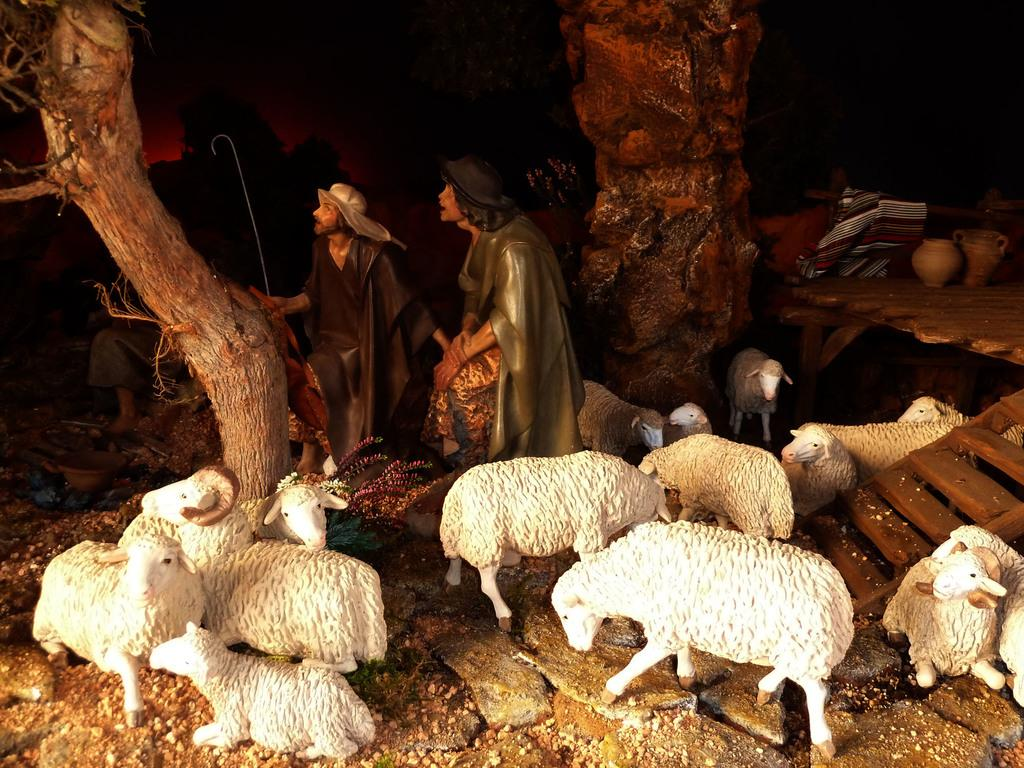What type of animals are present in the image? There are artificial sheep in the image. How many people are in the image? There are two persons in the image. What can be seen on the left side of the image? There is a tree on the left side of the image. What type of wing is visible on the artificial sheep in the image? There are no wings visible on the artificial sheep in the image. What day of the week is depicted in the image? The day of the week is not mentioned or depicted in the image. 